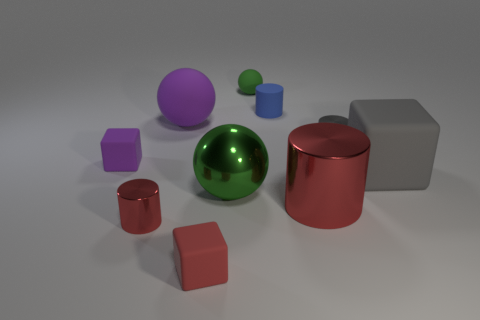Subtract 1 cylinders. How many cylinders are left? 3 Subtract all blocks. How many objects are left? 7 Subtract all big purple rubber objects. Subtract all large shiny cylinders. How many objects are left? 8 Add 1 big red cylinders. How many big red cylinders are left? 2 Add 7 small green matte things. How many small green matte things exist? 8 Subtract 0 yellow cubes. How many objects are left? 10 